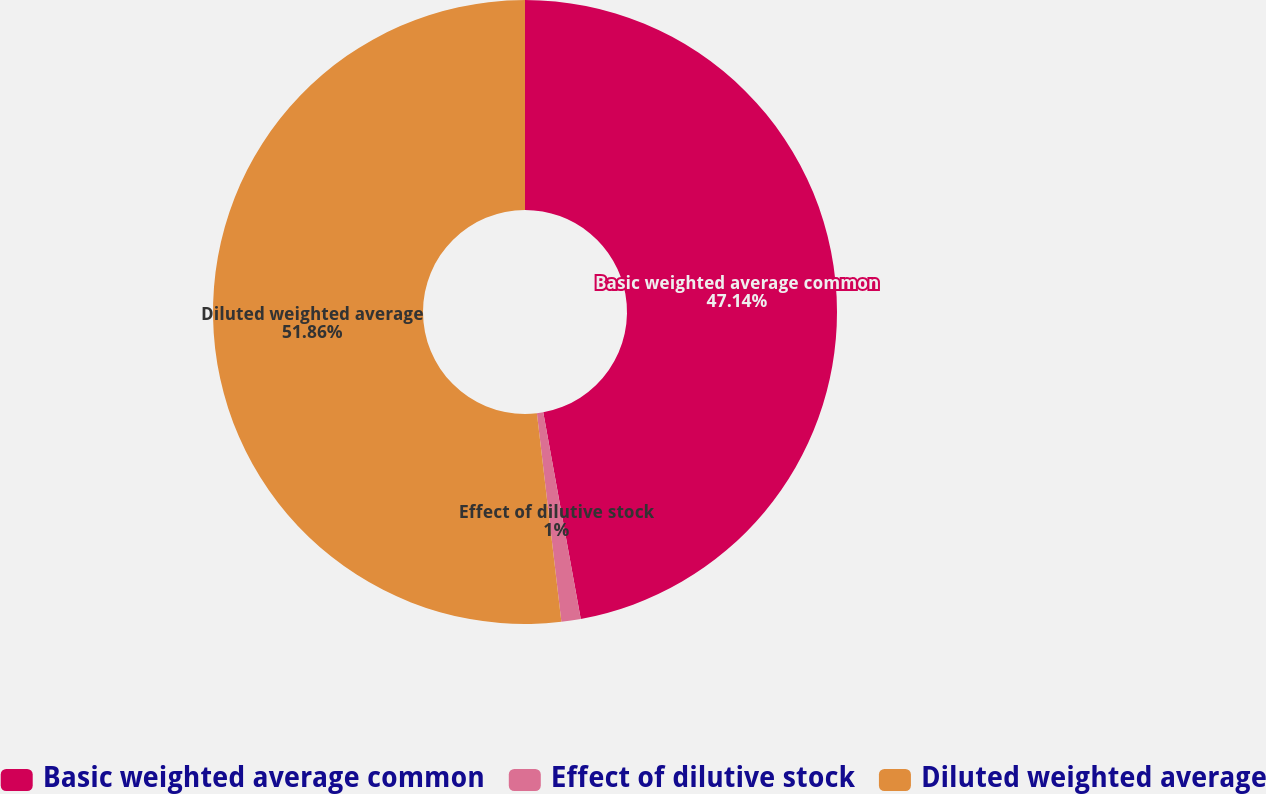Convert chart to OTSL. <chart><loc_0><loc_0><loc_500><loc_500><pie_chart><fcel>Basic weighted average common<fcel>Effect of dilutive stock<fcel>Diluted weighted average<nl><fcel>47.14%<fcel>1.0%<fcel>51.86%<nl></chart> 